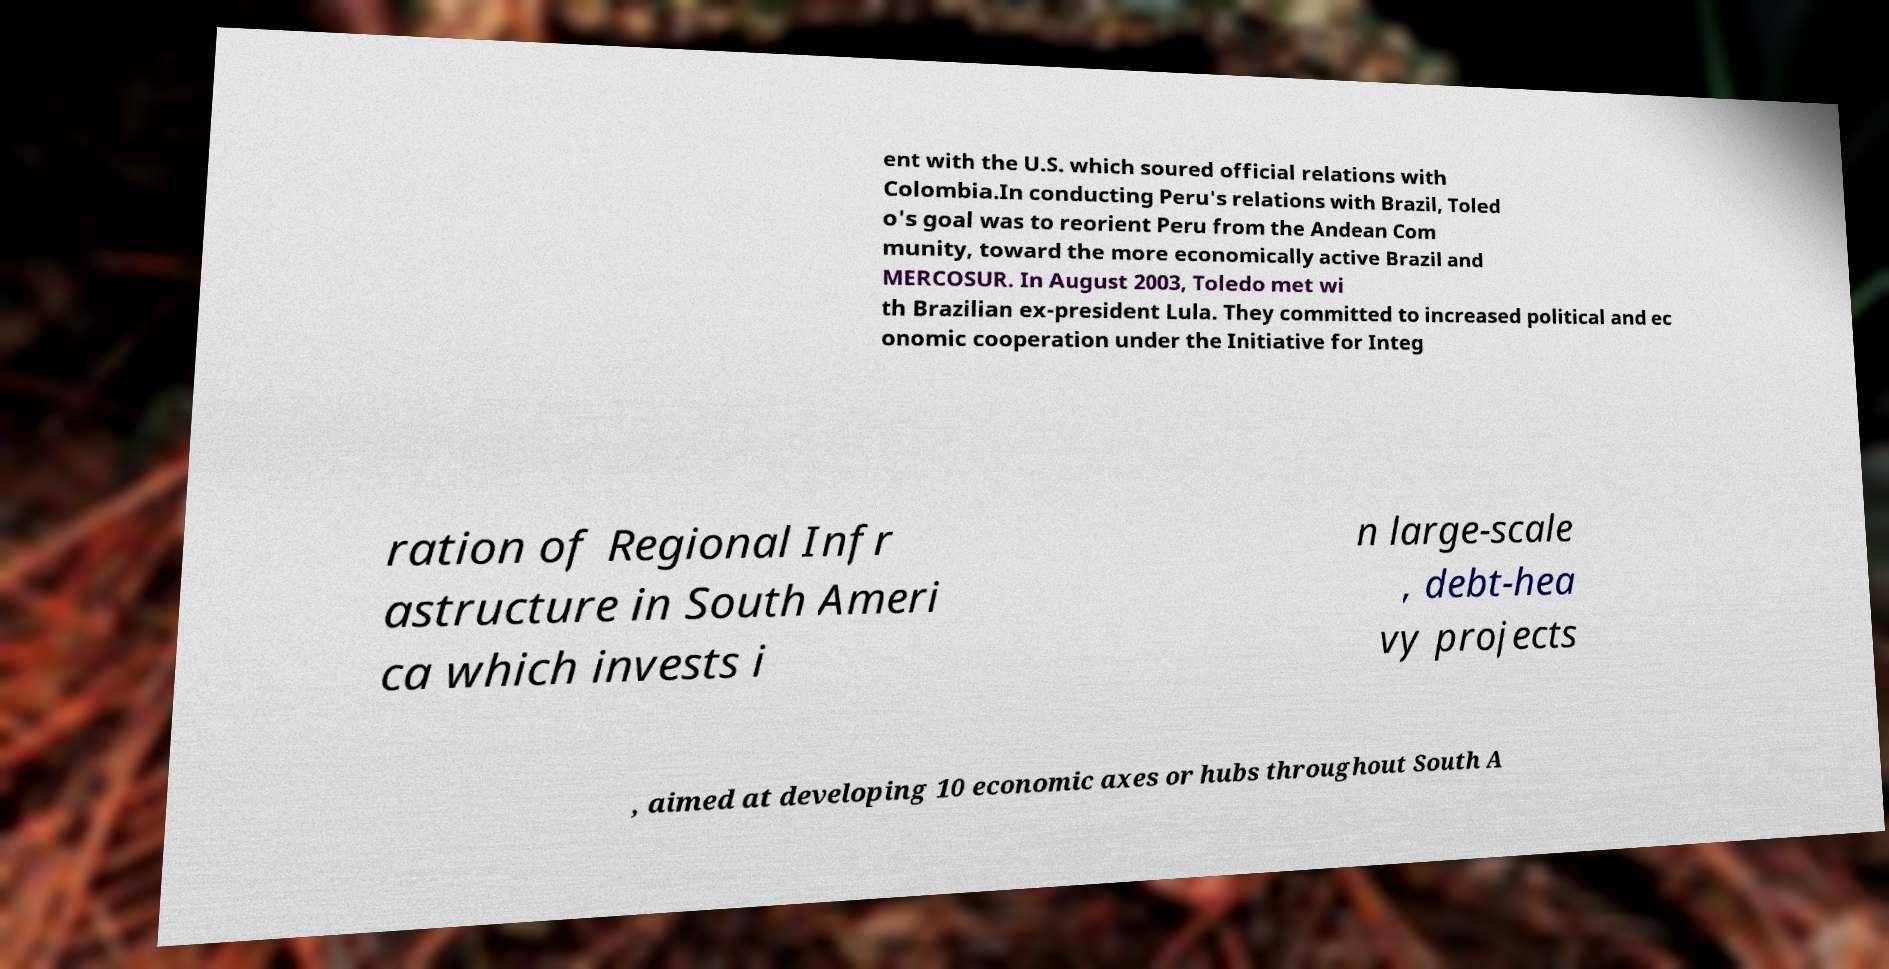Please identify and transcribe the text found in this image. ent with the U.S. which soured official relations with Colombia.In conducting Peru's relations with Brazil, Toled o's goal was to reorient Peru from the Andean Com munity, toward the more economically active Brazil and MERCOSUR. In August 2003, Toledo met wi th Brazilian ex-president Lula. They committed to increased political and ec onomic cooperation under the Initiative for Integ ration of Regional Infr astructure in South Ameri ca which invests i n large-scale , debt-hea vy projects , aimed at developing 10 economic axes or hubs throughout South A 